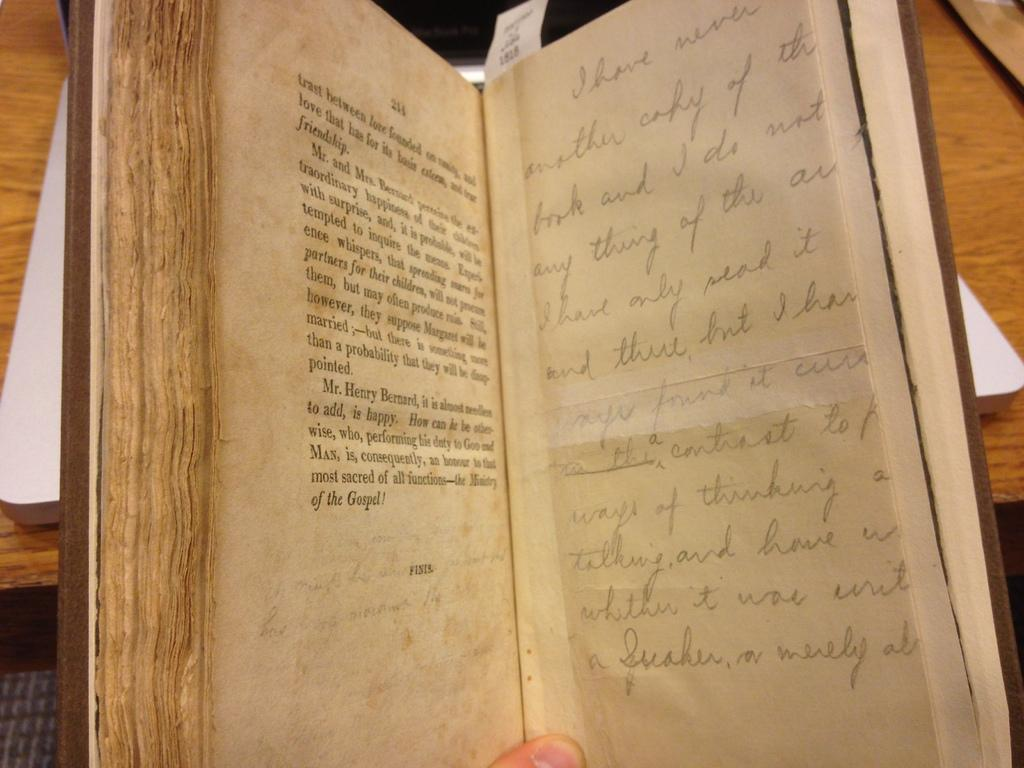<image>
Provide a brief description of the given image. An old warn book with both type and handwriting is open to page 214. 